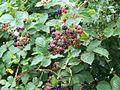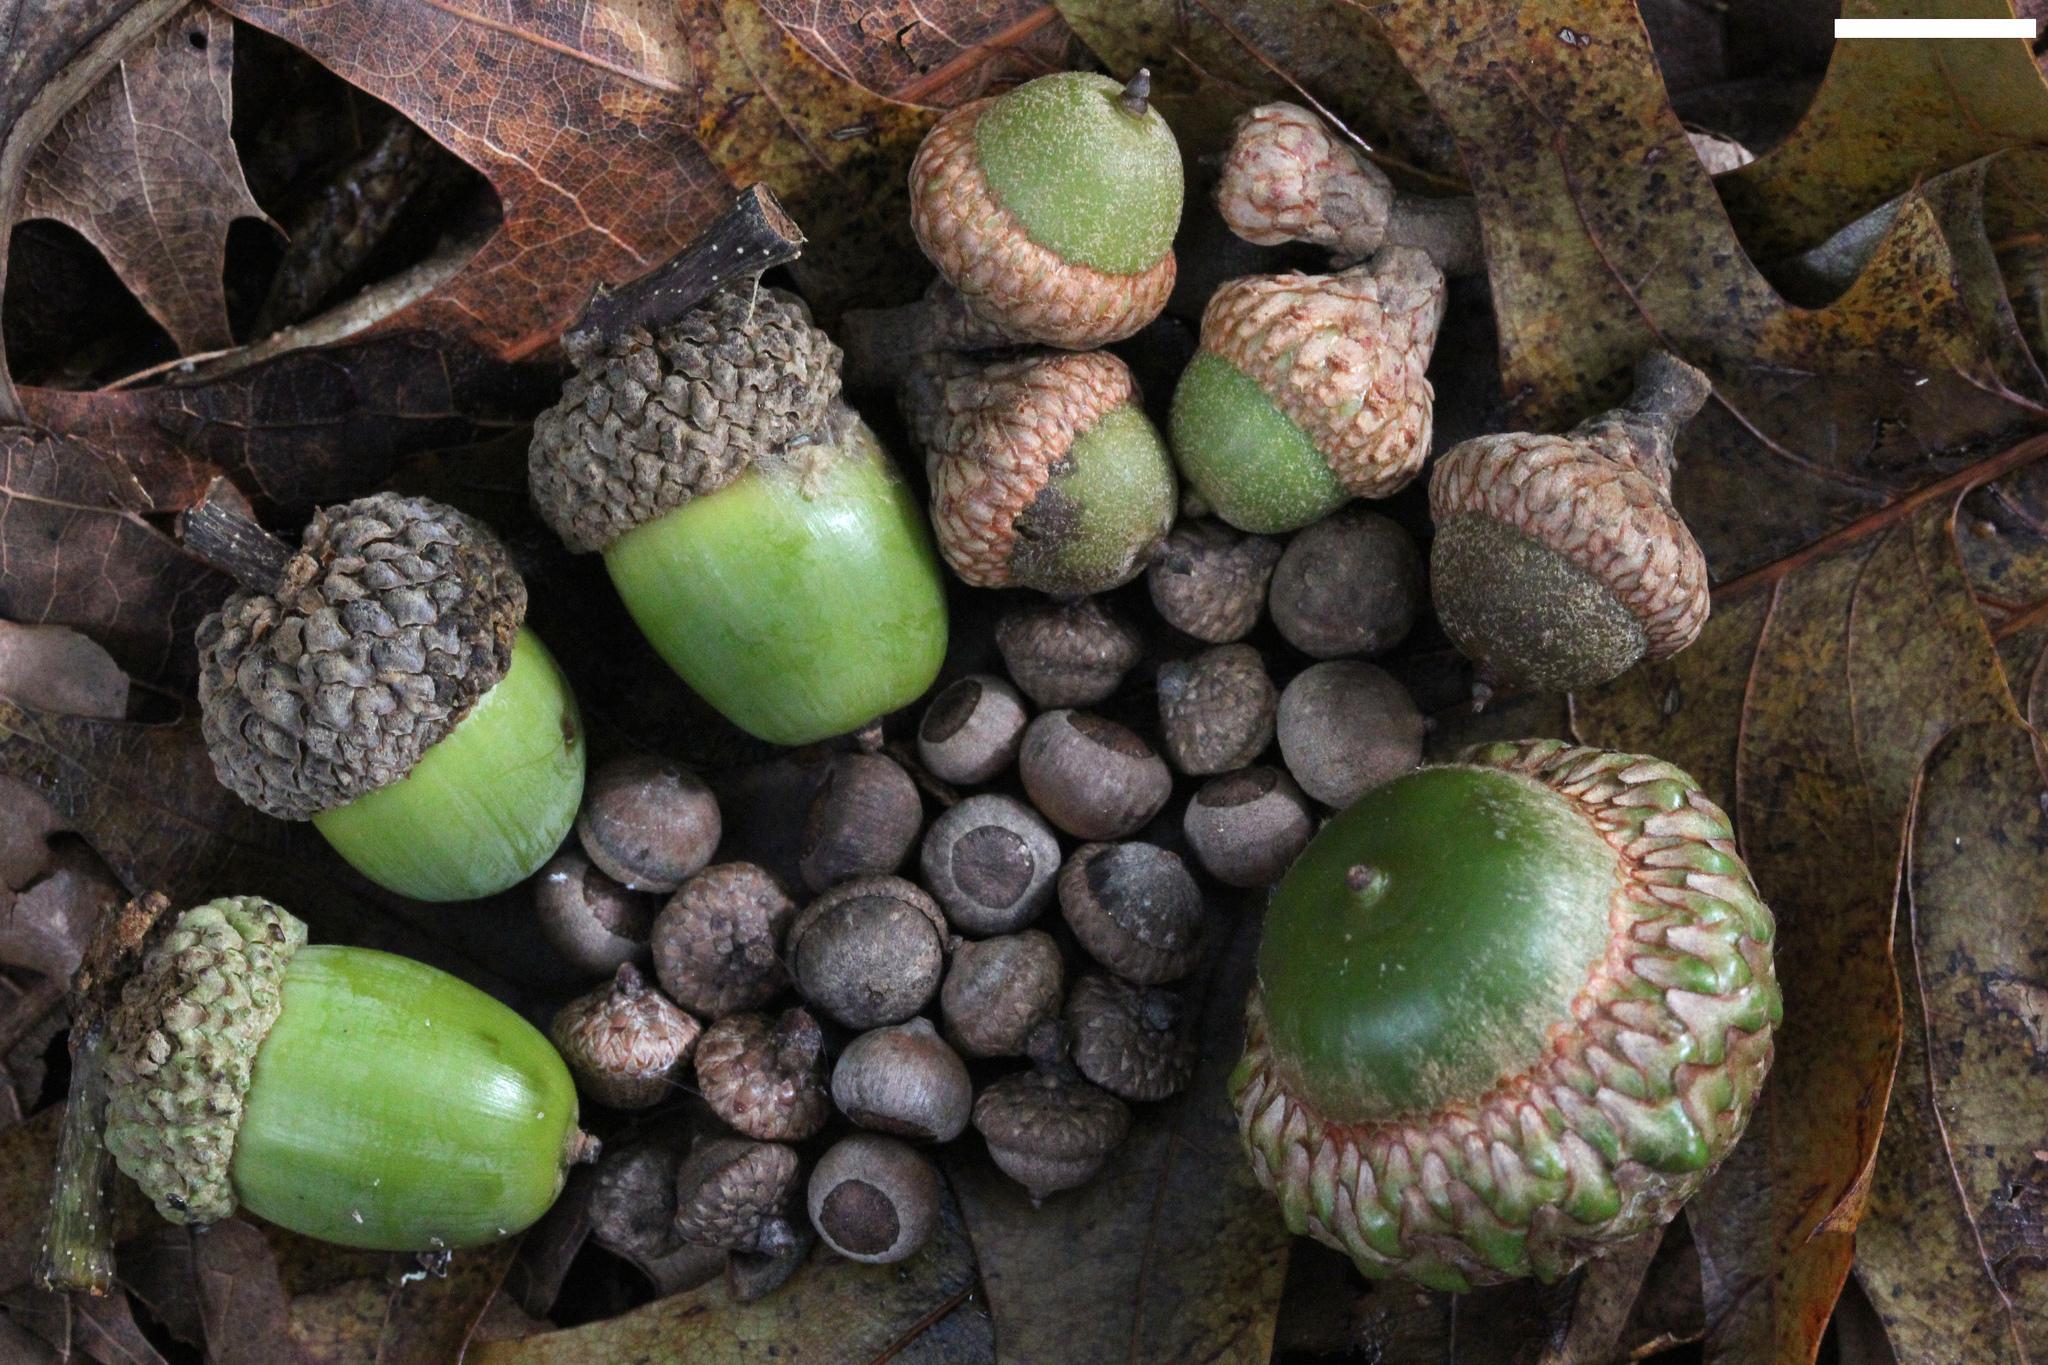The first image is the image on the left, the second image is the image on the right. Considering the images on both sides, is "Each image shows acorns growing on a tree with green leaves, and in total, most acorns are green and most acorns are slender." valid? Answer yes or no. No. The first image is the image on the left, the second image is the image on the right. For the images displayed, is the sentence "Acorns are growing on trees in each of the images." factually correct? Answer yes or no. No. 